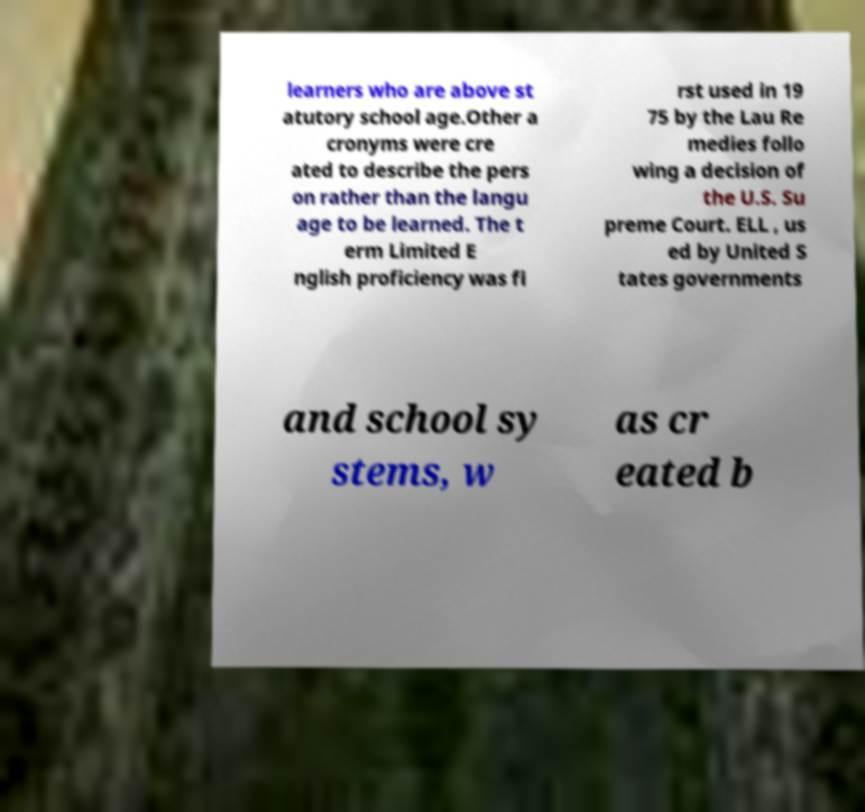For documentation purposes, I need the text within this image transcribed. Could you provide that? learners who are above st atutory school age.Other a cronyms were cre ated to describe the pers on rather than the langu age to be learned. The t erm Limited E nglish proficiency was fi rst used in 19 75 by the Lau Re medies follo wing a decision of the U.S. Su preme Court. ELL , us ed by United S tates governments and school sy stems, w as cr eated b 